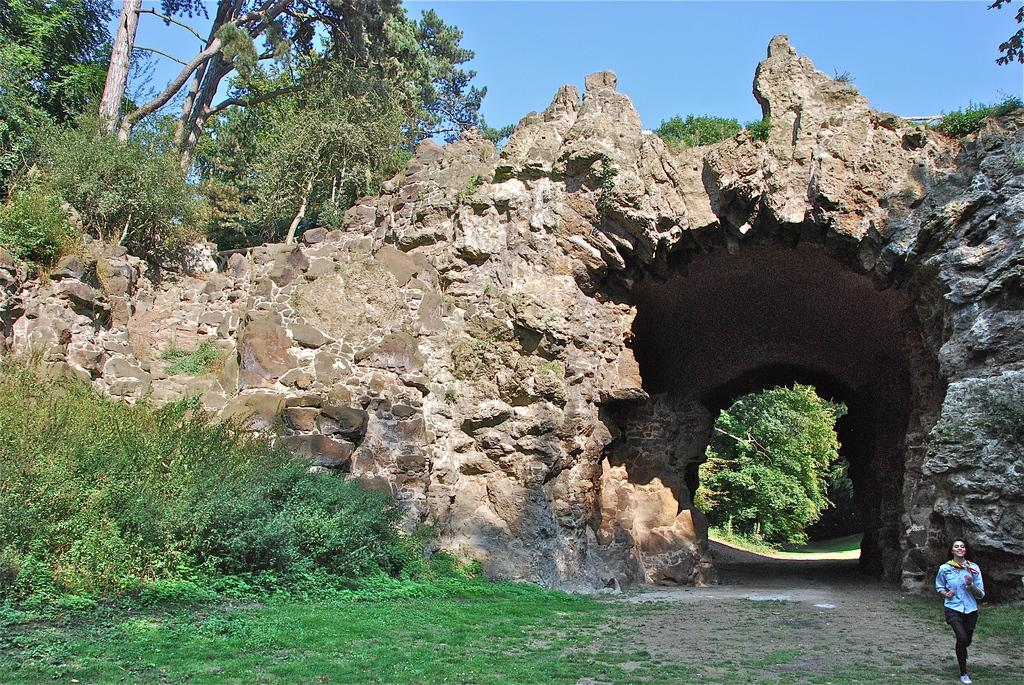What type of natural formation is depicted in the image? The image appears to depict a cave with an arch. What is the woman in the image doing? There is a woman running in the image. What type of vegetation can be seen in the image? Trees, plants, and grass are visible in the image. What type of suit is the woman wearing while swimming in the image? There is no woman swimming in the image, nor is there any mention of a suit. 